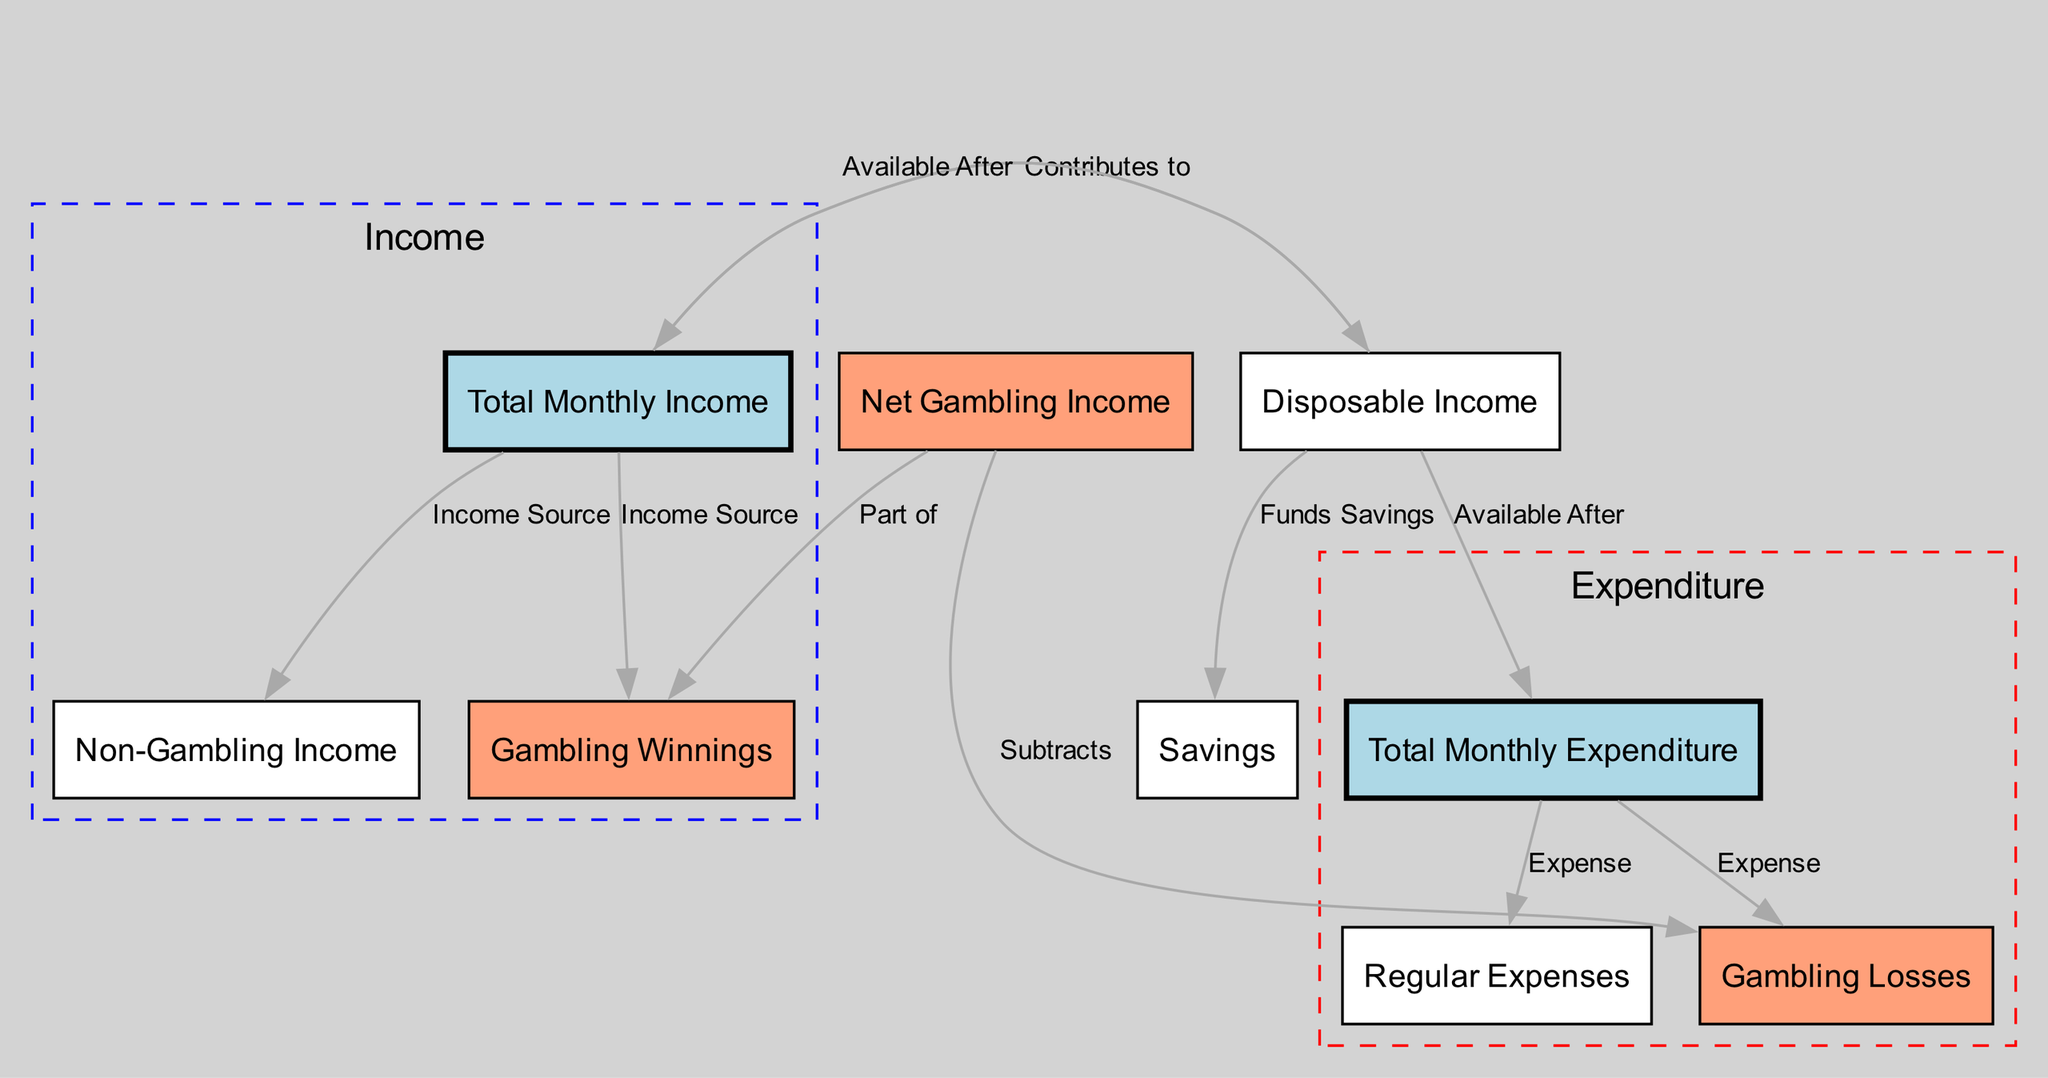What is the total monthly income? The total monthly income is represented in the diagram by the node labeled "Total Monthly Income." Since the exact number is not provided in the data, we will state it is the total derived from all specified income sources.
Answer: Total Monthly Income What are the types of income sources? The income sources indicated in the diagram include "Non-Gambling Income" and "Gambling Winnings," both directly connected to the "Total Monthly Income" node.
Answer: Non-Gambling Income, Gambling Winnings What is included in total monthly expenditure? The total monthly expenditure encompasses "Regular Expenses" and "Gambling Losses," which are indicated as directly connected to the "Total Monthly Expenditure" node.
Answer: Regular Expenses, Gambling Losses How is net gambling income calculated? The net gambling income is calculated by subtracting "Gambling Losses" from "Gambling Winnings," as shown by the edge connecting these two nodes to "Net Gambling Income."
Answer: Gambling Winnings minus Gambling Losses What type of expenses contribute to total monthly expenditure? The total monthly expenditure is contributed by both "Regular Expenses" and "Gambling Losses," which are highlighted as expenses in the diagram.
Answer: Regular Expenses, Gambling Losses Which component represents the income available after regular expenses? The "Disposable Income" node represents the income available after regular expenses, as indicated by the edges connecting it to both "Total Monthly Income" and "Total Monthly Expenditure."
Answer: Disposable Income What funds are set aside for savings? The funds available for savings come from the "Disposable Income," which is directed towards the "Savings" node in the diagram.
Answer: Savings How many nodes are present in this diagram? By counting the nodes listed in the diagram, including all income and expenditure categories, there are a total of nine distinct nodes.
Answer: Nine What expenditure is part of total monthly expenditure? The total monthly expenditure consists of both "Regular Expenses" and "Gambling Losses," as connected in the diagram.
Answer: Regular Expenses, Gambling Losses 